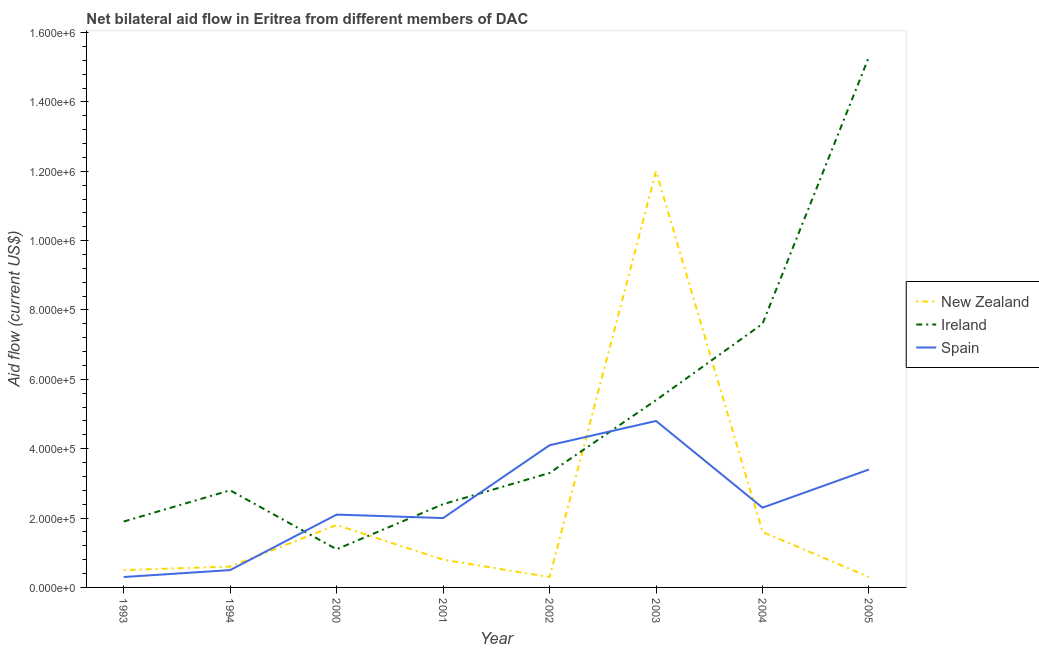Does the line corresponding to amount of aid provided by ireland intersect with the line corresponding to amount of aid provided by spain?
Your answer should be compact. Yes. Is the number of lines equal to the number of legend labels?
Keep it short and to the point. Yes. What is the amount of aid provided by ireland in 2001?
Provide a succinct answer. 2.40e+05. Across all years, what is the maximum amount of aid provided by new zealand?
Offer a terse response. 1.20e+06. Across all years, what is the minimum amount of aid provided by ireland?
Give a very brief answer. 1.10e+05. In which year was the amount of aid provided by new zealand maximum?
Provide a short and direct response. 2003. What is the total amount of aid provided by spain in the graph?
Provide a succinct answer. 1.95e+06. What is the difference between the amount of aid provided by ireland in 2002 and that in 2003?
Offer a terse response. -2.10e+05. What is the difference between the amount of aid provided by spain in 2005 and the amount of aid provided by new zealand in 1993?
Offer a terse response. 2.90e+05. What is the average amount of aid provided by spain per year?
Provide a short and direct response. 2.44e+05. In the year 2003, what is the difference between the amount of aid provided by spain and amount of aid provided by ireland?
Your answer should be very brief. -6.00e+04. In how many years, is the amount of aid provided by ireland greater than 600000 US$?
Provide a succinct answer. 2. What is the ratio of the amount of aid provided by ireland in 1993 to that in 2001?
Your answer should be compact. 0.79. Is the amount of aid provided by ireland in 2000 less than that in 2004?
Keep it short and to the point. Yes. Is the difference between the amount of aid provided by spain in 1993 and 2002 greater than the difference between the amount of aid provided by ireland in 1993 and 2002?
Keep it short and to the point. No. What is the difference between the highest and the lowest amount of aid provided by spain?
Ensure brevity in your answer.  4.50e+05. Is the sum of the amount of aid provided by new zealand in 2002 and 2003 greater than the maximum amount of aid provided by spain across all years?
Offer a terse response. Yes. Is it the case that in every year, the sum of the amount of aid provided by new zealand and amount of aid provided by ireland is greater than the amount of aid provided by spain?
Ensure brevity in your answer.  No. Does the amount of aid provided by ireland monotonically increase over the years?
Make the answer very short. No. Is the amount of aid provided by new zealand strictly greater than the amount of aid provided by ireland over the years?
Ensure brevity in your answer.  No. How many lines are there?
Give a very brief answer. 3. Does the graph contain any zero values?
Make the answer very short. No. Does the graph contain grids?
Give a very brief answer. No. Where does the legend appear in the graph?
Your answer should be compact. Center right. What is the title of the graph?
Your answer should be compact. Net bilateral aid flow in Eritrea from different members of DAC. Does "Refusal of sex" appear as one of the legend labels in the graph?
Make the answer very short. No. What is the label or title of the X-axis?
Your answer should be very brief. Year. What is the Aid flow (current US$) in New Zealand in 1993?
Make the answer very short. 5.00e+04. What is the Aid flow (current US$) in Ireland in 1993?
Offer a very short reply. 1.90e+05. What is the Aid flow (current US$) of New Zealand in 1994?
Your answer should be compact. 6.00e+04. What is the Aid flow (current US$) in Ireland in 1994?
Your response must be concise. 2.80e+05. What is the Aid flow (current US$) of New Zealand in 2000?
Provide a short and direct response. 1.80e+05. What is the Aid flow (current US$) of Spain in 2000?
Keep it short and to the point. 2.10e+05. What is the Aid flow (current US$) in New Zealand in 2001?
Keep it short and to the point. 8.00e+04. What is the Aid flow (current US$) of Ireland in 2001?
Your answer should be very brief. 2.40e+05. What is the Aid flow (current US$) of New Zealand in 2002?
Your response must be concise. 3.00e+04. What is the Aid flow (current US$) of Ireland in 2002?
Keep it short and to the point. 3.30e+05. What is the Aid flow (current US$) in Spain in 2002?
Your answer should be compact. 4.10e+05. What is the Aid flow (current US$) in New Zealand in 2003?
Provide a succinct answer. 1.20e+06. What is the Aid flow (current US$) of Ireland in 2003?
Your answer should be very brief. 5.40e+05. What is the Aid flow (current US$) of New Zealand in 2004?
Offer a very short reply. 1.60e+05. What is the Aid flow (current US$) of Ireland in 2004?
Provide a short and direct response. 7.60e+05. What is the Aid flow (current US$) of Ireland in 2005?
Your response must be concise. 1.53e+06. What is the Aid flow (current US$) of Spain in 2005?
Offer a very short reply. 3.40e+05. Across all years, what is the maximum Aid flow (current US$) in New Zealand?
Your answer should be compact. 1.20e+06. Across all years, what is the maximum Aid flow (current US$) in Ireland?
Make the answer very short. 1.53e+06. Across all years, what is the minimum Aid flow (current US$) in New Zealand?
Your response must be concise. 3.00e+04. Across all years, what is the minimum Aid flow (current US$) of Ireland?
Provide a succinct answer. 1.10e+05. Across all years, what is the minimum Aid flow (current US$) in Spain?
Keep it short and to the point. 3.00e+04. What is the total Aid flow (current US$) of New Zealand in the graph?
Offer a very short reply. 1.79e+06. What is the total Aid flow (current US$) in Ireland in the graph?
Make the answer very short. 3.98e+06. What is the total Aid flow (current US$) in Spain in the graph?
Your answer should be compact. 1.95e+06. What is the difference between the Aid flow (current US$) of Ireland in 1993 and that in 1994?
Offer a terse response. -9.00e+04. What is the difference between the Aid flow (current US$) of Spain in 1993 and that in 1994?
Offer a very short reply. -2.00e+04. What is the difference between the Aid flow (current US$) in Ireland in 1993 and that in 2000?
Make the answer very short. 8.00e+04. What is the difference between the Aid flow (current US$) of New Zealand in 1993 and that in 2001?
Give a very brief answer. -3.00e+04. What is the difference between the Aid flow (current US$) in Ireland in 1993 and that in 2001?
Your response must be concise. -5.00e+04. What is the difference between the Aid flow (current US$) of Ireland in 1993 and that in 2002?
Provide a short and direct response. -1.40e+05. What is the difference between the Aid flow (current US$) of Spain in 1993 and that in 2002?
Your answer should be compact. -3.80e+05. What is the difference between the Aid flow (current US$) in New Zealand in 1993 and that in 2003?
Offer a terse response. -1.15e+06. What is the difference between the Aid flow (current US$) of Ireland in 1993 and that in 2003?
Your answer should be compact. -3.50e+05. What is the difference between the Aid flow (current US$) in Spain in 1993 and that in 2003?
Offer a very short reply. -4.50e+05. What is the difference between the Aid flow (current US$) of New Zealand in 1993 and that in 2004?
Offer a very short reply. -1.10e+05. What is the difference between the Aid flow (current US$) of Ireland in 1993 and that in 2004?
Keep it short and to the point. -5.70e+05. What is the difference between the Aid flow (current US$) in Spain in 1993 and that in 2004?
Keep it short and to the point. -2.00e+05. What is the difference between the Aid flow (current US$) in New Zealand in 1993 and that in 2005?
Offer a terse response. 2.00e+04. What is the difference between the Aid flow (current US$) of Ireland in 1993 and that in 2005?
Provide a short and direct response. -1.34e+06. What is the difference between the Aid flow (current US$) in Spain in 1993 and that in 2005?
Ensure brevity in your answer.  -3.10e+05. What is the difference between the Aid flow (current US$) in Spain in 1994 and that in 2000?
Make the answer very short. -1.60e+05. What is the difference between the Aid flow (current US$) in New Zealand in 1994 and that in 2001?
Provide a short and direct response. -2.00e+04. What is the difference between the Aid flow (current US$) of Spain in 1994 and that in 2001?
Make the answer very short. -1.50e+05. What is the difference between the Aid flow (current US$) of Spain in 1994 and that in 2002?
Ensure brevity in your answer.  -3.60e+05. What is the difference between the Aid flow (current US$) in New Zealand in 1994 and that in 2003?
Offer a terse response. -1.14e+06. What is the difference between the Aid flow (current US$) in Ireland in 1994 and that in 2003?
Your response must be concise. -2.60e+05. What is the difference between the Aid flow (current US$) of Spain in 1994 and that in 2003?
Your answer should be very brief. -4.30e+05. What is the difference between the Aid flow (current US$) of New Zealand in 1994 and that in 2004?
Your answer should be very brief. -1.00e+05. What is the difference between the Aid flow (current US$) of Ireland in 1994 and that in 2004?
Offer a very short reply. -4.80e+05. What is the difference between the Aid flow (current US$) of Spain in 1994 and that in 2004?
Make the answer very short. -1.80e+05. What is the difference between the Aid flow (current US$) in Ireland in 1994 and that in 2005?
Keep it short and to the point. -1.25e+06. What is the difference between the Aid flow (current US$) in Spain in 2000 and that in 2001?
Provide a short and direct response. 10000. What is the difference between the Aid flow (current US$) in Spain in 2000 and that in 2002?
Provide a succinct answer. -2.00e+05. What is the difference between the Aid flow (current US$) of New Zealand in 2000 and that in 2003?
Make the answer very short. -1.02e+06. What is the difference between the Aid flow (current US$) of Ireland in 2000 and that in 2003?
Ensure brevity in your answer.  -4.30e+05. What is the difference between the Aid flow (current US$) of New Zealand in 2000 and that in 2004?
Provide a short and direct response. 2.00e+04. What is the difference between the Aid flow (current US$) of Ireland in 2000 and that in 2004?
Your answer should be very brief. -6.50e+05. What is the difference between the Aid flow (current US$) in Spain in 2000 and that in 2004?
Ensure brevity in your answer.  -2.00e+04. What is the difference between the Aid flow (current US$) in Ireland in 2000 and that in 2005?
Provide a short and direct response. -1.42e+06. What is the difference between the Aid flow (current US$) of New Zealand in 2001 and that in 2002?
Provide a succinct answer. 5.00e+04. What is the difference between the Aid flow (current US$) in Spain in 2001 and that in 2002?
Provide a short and direct response. -2.10e+05. What is the difference between the Aid flow (current US$) of New Zealand in 2001 and that in 2003?
Ensure brevity in your answer.  -1.12e+06. What is the difference between the Aid flow (current US$) in Spain in 2001 and that in 2003?
Make the answer very short. -2.80e+05. What is the difference between the Aid flow (current US$) of New Zealand in 2001 and that in 2004?
Keep it short and to the point. -8.00e+04. What is the difference between the Aid flow (current US$) of Ireland in 2001 and that in 2004?
Make the answer very short. -5.20e+05. What is the difference between the Aid flow (current US$) in Spain in 2001 and that in 2004?
Your response must be concise. -3.00e+04. What is the difference between the Aid flow (current US$) of Ireland in 2001 and that in 2005?
Offer a terse response. -1.29e+06. What is the difference between the Aid flow (current US$) in New Zealand in 2002 and that in 2003?
Your answer should be compact. -1.17e+06. What is the difference between the Aid flow (current US$) in Ireland in 2002 and that in 2003?
Give a very brief answer. -2.10e+05. What is the difference between the Aid flow (current US$) in New Zealand in 2002 and that in 2004?
Give a very brief answer. -1.30e+05. What is the difference between the Aid flow (current US$) of Ireland in 2002 and that in 2004?
Provide a short and direct response. -4.30e+05. What is the difference between the Aid flow (current US$) of Spain in 2002 and that in 2004?
Make the answer very short. 1.80e+05. What is the difference between the Aid flow (current US$) in New Zealand in 2002 and that in 2005?
Your answer should be compact. 0. What is the difference between the Aid flow (current US$) in Ireland in 2002 and that in 2005?
Your answer should be compact. -1.20e+06. What is the difference between the Aid flow (current US$) of Spain in 2002 and that in 2005?
Provide a short and direct response. 7.00e+04. What is the difference between the Aid flow (current US$) in New Zealand in 2003 and that in 2004?
Provide a succinct answer. 1.04e+06. What is the difference between the Aid flow (current US$) of Ireland in 2003 and that in 2004?
Give a very brief answer. -2.20e+05. What is the difference between the Aid flow (current US$) in New Zealand in 2003 and that in 2005?
Make the answer very short. 1.17e+06. What is the difference between the Aid flow (current US$) of Ireland in 2003 and that in 2005?
Your answer should be compact. -9.90e+05. What is the difference between the Aid flow (current US$) of New Zealand in 2004 and that in 2005?
Keep it short and to the point. 1.30e+05. What is the difference between the Aid flow (current US$) in Ireland in 2004 and that in 2005?
Offer a very short reply. -7.70e+05. What is the difference between the Aid flow (current US$) of New Zealand in 1993 and the Aid flow (current US$) of Ireland in 1994?
Keep it short and to the point. -2.30e+05. What is the difference between the Aid flow (current US$) in New Zealand in 1993 and the Aid flow (current US$) in Spain in 1994?
Ensure brevity in your answer.  0. What is the difference between the Aid flow (current US$) of New Zealand in 1993 and the Aid flow (current US$) of Ireland in 2000?
Offer a very short reply. -6.00e+04. What is the difference between the Aid flow (current US$) in New Zealand in 1993 and the Aid flow (current US$) in Spain in 2000?
Your response must be concise. -1.60e+05. What is the difference between the Aid flow (current US$) in Ireland in 1993 and the Aid flow (current US$) in Spain in 2000?
Offer a very short reply. -2.00e+04. What is the difference between the Aid flow (current US$) in New Zealand in 1993 and the Aid flow (current US$) in Ireland in 2001?
Your response must be concise. -1.90e+05. What is the difference between the Aid flow (current US$) of New Zealand in 1993 and the Aid flow (current US$) of Spain in 2001?
Your answer should be compact. -1.50e+05. What is the difference between the Aid flow (current US$) of New Zealand in 1993 and the Aid flow (current US$) of Ireland in 2002?
Keep it short and to the point. -2.80e+05. What is the difference between the Aid flow (current US$) in New Zealand in 1993 and the Aid flow (current US$) in Spain in 2002?
Ensure brevity in your answer.  -3.60e+05. What is the difference between the Aid flow (current US$) in Ireland in 1993 and the Aid flow (current US$) in Spain in 2002?
Your response must be concise. -2.20e+05. What is the difference between the Aid flow (current US$) of New Zealand in 1993 and the Aid flow (current US$) of Ireland in 2003?
Your response must be concise. -4.90e+05. What is the difference between the Aid flow (current US$) in New Zealand in 1993 and the Aid flow (current US$) in Spain in 2003?
Keep it short and to the point. -4.30e+05. What is the difference between the Aid flow (current US$) of New Zealand in 1993 and the Aid flow (current US$) of Ireland in 2004?
Offer a terse response. -7.10e+05. What is the difference between the Aid flow (current US$) of New Zealand in 1993 and the Aid flow (current US$) of Spain in 2004?
Provide a succinct answer. -1.80e+05. What is the difference between the Aid flow (current US$) in Ireland in 1993 and the Aid flow (current US$) in Spain in 2004?
Offer a terse response. -4.00e+04. What is the difference between the Aid flow (current US$) in New Zealand in 1993 and the Aid flow (current US$) in Ireland in 2005?
Your answer should be very brief. -1.48e+06. What is the difference between the Aid flow (current US$) in Ireland in 1993 and the Aid flow (current US$) in Spain in 2005?
Offer a very short reply. -1.50e+05. What is the difference between the Aid flow (current US$) of New Zealand in 1994 and the Aid flow (current US$) of Ireland in 2000?
Offer a terse response. -5.00e+04. What is the difference between the Aid flow (current US$) of Ireland in 1994 and the Aid flow (current US$) of Spain in 2000?
Ensure brevity in your answer.  7.00e+04. What is the difference between the Aid flow (current US$) of New Zealand in 1994 and the Aid flow (current US$) of Spain in 2001?
Provide a succinct answer. -1.40e+05. What is the difference between the Aid flow (current US$) of Ireland in 1994 and the Aid flow (current US$) of Spain in 2001?
Offer a terse response. 8.00e+04. What is the difference between the Aid flow (current US$) of New Zealand in 1994 and the Aid flow (current US$) of Spain in 2002?
Ensure brevity in your answer.  -3.50e+05. What is the difference between the Aid flow (current US$) of Ireland in 1994 and the Aid flow (current US$) of Spain in 2002?
Your answer should be compact. -1.30e+05. What is the difference between the Aid flow (current US$) of New Zealand in 1994 and the Aid flow (current US$) of Ireland in 2003?
Offer a terse response. -4.80e+05. What is the difference between the Aid flow (current US$) of New Zealand in 1994 and the Aid flow (current US$) of Spain in 2003?
Ensure brevity in your answer.  -4.20e+05. What is the difference between the Aid flow (current US$) of Ireland in 1994 and the Aid flow (current US$) of Spain in 2003?
Provide a succinct answer. -2.00e+05. What is the difference between the Aid flow (current US$) of New Zealand in 1994 and the Aid flow (current US$) of Ireland in 2004?
Offer a terse response. -7.00e+05. What is the difference between the Aid flow (current US$) in New Zealand in 1994 and the Aid flow (current US$) in Spain in 2004?
Offer a terse response. -1.70e+05. What is the difference between the Aid flow (current US$) of Ireland in 1994 and the Aid flow (current US$) of Spain in 2004?
Offer a very short reply. 5.00e+04. What is the difference between the Aid flow (current US$) of New Zealand in 1994 and the Aid flow (current US$) of Ireland in 2005?
Offer a terse response. -1.47e+06. What is the difference between the Aid flow (current US$) in New Zealand in 1994 and the Aid flow (current US$) in Spain in 2005?
Make the answer very short. -2.80e+05. What is the difference between the Aid flow (current US$) of New Zealand in 2000 and the Aid flow (current US$) of Spain in 2002?
Your response must be concise. -2.30e+05. What is the difference between the Aid flow (current US$) of New Zealand in 2000 and the Aid flow (current US$) of Ireland in 2003?
Keep it short and to the point. -3.60e+05. What is the difference between the Aid flow (current US$) of Ireland in 2000 and the Aid flow (current US$) of Spain in 2003?
Keep it short and to the point. -3.70e+05. What is the difference between the Aid flow (current US$) of New Zealand in 2000 and the Aid flow (current US$) of Ireland in 2004?
Give a very brief answer. -5.80e+05. What is the difference between the Aid flow (current US$) in New Zealand in 2000 and the Aid flow (current US$) in Spain in 2004?
Your answer should be compact. -5.00e+04. What is the difference between the Aid flow (current US$) in New Zealand in 2000 and the Aid flow (current US$) in Ireland in 2005?
Give a very brief answer. -1.35e+06. What is the difference between the Aid flow (current US$) of New Zealand in 2000 and the Aid flow (current US$) of Spain in 2005?
Offer a terse response. -1.60e+05. What is the difference between the Aid flow (current US$) of New Zealand in 2001 and the Aid flow (current US$) of Ireland in 2002?
Keep it short and to the point. -2.50e+05. What is the difference between the Aid flow (current US$) in New Zealand in 2001 and the Aid flow (current US$) in Spain in 2002?
Your answer should be very brief. -3.30e+05. What is the difference between the Aid flow (current US$) of New Zealand in 2001 and the Aid flow (current US$) of Ireland in 2003?
Keep it short and to the point. -4.60e+05. What is the difference between the Aid flow (current US$) of New Zealand in 2001 and the Aid flow (current US$) of Spain in 2003?
Give a very brief answer. -4.00e+05. What is the difference between the Aid flow (current US$) of Ireland in 2001 and the Aid flow (current US$) of Spain in 2003?
Offer a terse response. -2.40e+05. What is the difference between the Aid flow (current US$) in New Zealand in 2001 and the Aid flow (current US$) in Ireland in 2004?
Keep it short and to the point. -6.80e+05. What is the difference between the Aid flow (current US$) in Ireland in 2001 and the Aid flow (current US$) in Spain in 2004?
Your response must be concise. 10000. What is the difference between the Aid flow (current US$) in New Zealand in 2001 and the Aid flow (current US$) in Ireland in 2005?
Keep it short and to the point. -1.45e+06. What is the difference between the Aid flow (current US$) of New Zealand in 2001 and the Aid flow (current US$) of Spain in 2005?
Keep it short and to the point. -2.60e+05. What is the difference between the Aid flow (current US$) of Ireland in 2001 and the Aid flow (current US$) of Spain in 2005?
Offer a very short reply. -1.00e+05. What is the difference between the Aid flow (current US$) in New Zealand in 2002 and the Aid flow (current US$) in Ireland in 2003?
Keep it short and to the point. -5.10e+05. What is the difference between the Aid flow (current US$) in New Zealand in 2002 and the Aid flow (current US$) in Spain in 2003?
Offer a very short reply. -4.50e+05. What is the difference between the Aid flow (current US$) in Ireland in 2002 and the Aid flow (current US$) in Spain in 2003?
Give a very brief answer. -1.50e+05. What is the difference between the Aid flow (current US$) in New Zealand in 2002 and the Aid flow (current US$) in Ireland in 2004?
Your response must be concise. -7.30e+05. What is the difference between the Aid flow (current US$) in New Zealand in 2002 and the Aid flow (current US$) in Spain in 2004?
Your answer should be very brief. -2.00e+05. What is the difference between the Aid flow (current US$) in New Zealand in 2002 and the Aid flow (current US$) in Ireland in 2005?
Provide a short and direct response. -1.50e+06. What is the difference between the Aid flow (current US$) in New Zealand in 2002 and the Aid flow (current US$) in Spain in 2005?
Offer a very short reply. -3.10e+05. What is the difference between the Aid flow (current US$) of Ireland in 2002 and the Aid flow (current US$) of Spain in 2005?
Offer a terse response. -10000. What is the difference between the Aid flow (current US$) of New Zealand in 2003 and the Aid flow (current US$) of Ireland in 2004?
Make the answer very short. 4.40e+05. What is the difference between the Aid flow (current US$) in New Zealand in 2003 and the Aid flow (current US$) in Spain in 2004?
Your answer should be very brief. 9.70e+05. What is the difference between the Aid flow (current US$) of Ireland in 2003 and the Aid flow (current US$) of Spain in 2004?
Give a very brief answer. 3.10e+05. What is the difference between the Aid flow (current US$) of New Zealand in 2003 and the Aid flow (current US$) of Ireland in 2005?
Offer a terse response. -3.30e+05. What is the difference between the Aid flow (current US$) of New Zealand in 2003 and the Aid flow (current US$) of Spain in 2005?
Provide a short and direct response. 8.60e+05. What is the difference between the Aid flow (current US$) of New Zealand in 2004 and the Aid flow (current US$) of Ireland in 2005?
Make the answer very short. -1.37e+06. What is the difference between the Aid flow (current US$) of New Zealand in 2004 and the Aid flow (current US$) of Spain in 2005?
Give a very brief answer. -1.80e+05. What is the average Aid flow (current US$) in New Zealand per year?
Provide a succinct answer. 2.24e+05. What is the average Aid flow (current US$) in Ireland per year?
Make the answer very short. 4.98e+05. What is the average Aid flow (current US$) of Spain per year?
Keep it short and to the point. 2.44e+05. In the year 1993, what is the difference between the Aid flow (current US$) of New Zealand and Aid flow (current US$) of Spain?
Your response must be concise. 2.00e+04. In the year 1993, what is the difference between the Aid flow (current US$) of Ireland and Aid flow (current US$) of Spain?
Your answer should be compact. 1.60e+05. In the year 1994, what is the difference between the Aid flow (current US$) of Ireland and Aid flow (current US$) of Spain?
Offer a very short reply. 2.30e+05. In the year 2000, what is the difference between the Aid flow (current US$) of New Zealand and Aid flow (current US$) of Ireland?
Keep it short and to the point. 7.00e+04. In the year 2000, what is the difference between the Aid flow (current US$) in New Zealand and Aid flow (current US$) in Spain?
Offer a terse response. -3.00e+04. In the year 2001, what is the difference between the Aid flow (current US$) of New Zealand and Aid flow (current US$) of Spain?
Give a very brief answer. -1.20e+05. In the year 2001, what is the difference between the Aid flow (current US$) of Ireland and Aid flow (current US$) of Spain?
Your answer should be very brief. 4.00e+04. In the year 2002, what is the difference between the Aid flow (current US$) of New Zealand and Aid flow (current US$) of Spain?
Your answer should be compact. -3.80e+05. In the year 2002, what is the difference between the Aid flow (current US$) in Ireland and Aid flow (current US$) in Spain?
Make the answer very short. -8.00e+04. In the year 2003, what is the difference between the Aid flow (current US$) of New Zealand and Aid flow (current US$) of Spain?
Your response must be concise. 7.20e+05. In the year 2003, what is the difference between the Aid flow (current US$) of Ireland and Aid flow (current US$) of Spain?
Keep it short and to the point. 6.00e+04. In the year 2004, what is the difference between the Aid flow (current US$) of New Zealand and Aid flow (current US$) of Ireland?
Your answer should be compact. -6.00e+05. In the year 2004, what is the difference between the Aid flow (current US$) in New Zealand and Aid flow (current US$) in Spain?
Offer a terse response. -7.00e+04. In the year 2004, what is the difference between the Aid flow (current US$) in Ireland and Aid flow (current US$) in Spain?
Give a very brief answer. 5.30e+05. In the year 2005, what is the difference between the Aid flow (current US$) in New Zealand and Aid flow (current US$) in Ireland?
Make the answer very short. -1.50e+06. In the year 2005, what is the difference between the Aid flow (current US$) of New Zealand and Aid flow (current US$) of Spain?
Give a very brief answer. -3.10e+05. In the year 2005, what is the difference between the Aid flow (current US$) of Ireland and Aid flow (current US$) of Spain?
Offer a terse response. 1.19e+06. What is the ratio of the Aid flow (current US$) of Ireland in 1993 to that in 1994?
Give a very brief answer. 0.68. What is the ratio of the Aid flow (current US$) of New Zealand in 1993 to that in 2000?
Provide a short and direct response. 0.28. What is the ratio of the Aid flow (current US$) in Ireland in 1993 to that in 2000?
Make the answer very short. 1.73. What is the ratio of the Aid flow (current US$) of Spain in 1993 to that in 2000?
Your response must be concise. 0.14. What is the ratio of the Aid flow (current US$) in New Zealand in 1993 to that in 2001?
Provide a succinct answer. 0.62. What is the ratio of the Aid flow (current US$) of Ireland in 1993 to that in 2001?
Your answer should be compact. 0.79. What is the ratio of the Aid flow (current US$) of Spain in 1993 to that in 2001?
Your answer should be very brief. 0.15. What is the ratio of the Aid flow (current US$) of New Zealand in 1993 to that in 2002?
Keep it short and to the point. 1.67. What is the ratio of the Aid flow (current US$) of Ireland in 1993 to that in 2002?
Provide a succinct answer. 0.58. What is the ratio of the Aid flow (current US$) of Spain in 1993 to that in 2002?
Your answer should be very brief. 0.07. What is the ratio of the Aid flow (current US$) of New Zealand in 1993 to that in 2003?
Offer a terse response. 0.04. What is the ratio of the Aid flow (current US$) in Ireland in 1993 to that in 2003?
Give a very brief answer. 0.35. What is the ratio of the Aid flow (current US$) in Spain in 1993 to that in 2003?
Provide a short and direct response. 0.06. What is the ratio of the Aid flow (current US$) of New Zealand in 1993 to that in 2004?
Provide a short and direct response. 0.31. What is the ratio of the Aid flow (current US$) of Ireland in 1993 to that in 2004?
Offer a terse response. 0.25. What is the ratio of the Aid flow (current US$) in Spain in 1993 to that in 2004?
Your answer should be very brief. 0.13. What is the ratio of the Aid flow (current US$) of Ireland in 1993 to that in 2005?
Offer a very short reply. 0.12. What is the ratio of the Aid flow (current US$) of Spain in 1993 to that in 2005?
Make the answer very short. 0.09. What is the ratio of the Aid flow (current US$) of New Zealand in 1994 to that in 2000?
Provide a succinct answer. 0.33. What is the ratio of the Aid flow (current US$) in Ireland in 1994 to that in 2000?
Keep it short and to the point. 2.55. What is the ratio of the Aid flow (current US$) of Spain in 1994 to that in 2000?
Your answer should be very brief. 0.24. What is the ratio of the Aid flow (current US$) of New Zealand in 1994 to that in 2001?
Your answer should be compact. 0.75. What is the ratio of the Aid flow (current US$) in Ireland in 1994 to that in 2001?
Keep it short and to the point. 1.17. What is the ratio of the Aid flow (current US$) of Spain in 1994 to that in 2001?
Your response must be concise. 0.25. What is the ratio of the Aid flow (current US$) of New Zealand in 1994 to that in 2002?
Ensure brevity in your answer.  2. What is the ratio of the Aid flow (current US$) in Ireland in 1994 to that in 2002?
Offer a terse response. 0.85. What is the ratio of the Aid flow (current US$) in Spain in 1994 to that in 2002?
Provide a short and direct response. 0.12. What is the ratio of the Aid flow (current US$) in New Zealand in 1994 to that in 2003?
Provide a succinct answer. 0.05. What is the ratio of the Aid flow (current US$) in Ireland in 1994 to that in 2003?
Provide a succinct answer. 0.52. What is the ratio of the Aid flow (current US$) of Spain in 1994 to that in 2003?
Offer a terse response. 0.1. What is the ratio of the Aid flow (current US$) of New Zealand in 1994 to that in 2004?
Offer a very short reply. 0.38. What is the ratio of the Aid flow (current US$) of Ireland in 1994 to that in 2004?
Ensure brevity in your answer.  0.37. What is the ratio of the Aid flow (current US$) of Spain in 1994 to that in 2004?
Your response must be concise. 0.22. What is the ratio of the Aid flow (current US$) of Ireland in 1994 to that in 2005?
Make the answer very short. 0.18. What is the ratio of the Aid flow (current US$) in Spain in 1994 to that in 2005?
Your answer should be very brief. 0.15. What is the ratio of the Aid flow (current US$) in New Zealand in 2000 to that in 2001?
Ensure brevity in your answer.  2.25. What is the ratio of the Aid flow (current US$) of Ireland in 2000 to that in 2001?
Give a very brief answer. 0.46. What is the ratio of the Aid flow (current US$) in Spain in 2000 to that in 2001?
Ensure brevity in your answer.  1.05. What is the ratio of the Aid flow (current US$) in New Zealand in 2000 to that in 2002?
Keep it short and to the point. 6. What is the ratio of the Aid flow (current US$) of Ireland in 2000 to that in 2002?
Give a very brief answer. 0.33. What is the ratio of the Aid flow (current US$) in Spain in 2000 to that in 2002?
Provide a succinct answer. 0.51. What is the ratio of the Aid flow (current US$) in Ireland in 2000 to that in 2003?
Offer a very short reply. 0.2. What is the ratio of the Aid flow (current US$) in Spain in 2000 to that in 2003?
Your answer should be compact. 0.44. What is the ratio of the Aid flow (current US$) in New Zealand in 2000 to that in 2004?
Give a very brief answer. 1.12. What is the ratio of the Aid flow (current US$) in Ireland in 2000 to that in 2004?
Offer a terse response. 0.14. What is the ratio of the Aid flow (current US$) in New Zealand in 2000 to that in 2005?
Offer a very short reply. 6. What is the ratio of the Aid flow (current US$) of Ireland in 2000 to that in 2005?
Provide a succinct answer. 0.07. What is the ratio of the Aid flow (current US$) in Spain in 2000 to that in 2005?
Your response must be concise. 0.62. What is the ratio of the Aid flow (current US$) of New Zealand in 2001 to that in 2002?
Provide a short and direct response. 2.67. What is the ratio of the Aid flow (current US$) in Ireland in 2001 to that in 2002?
Offer a very short reply. 0.73. What is the ratio of the Aid flow (current US$) of Spain in 2001 to that in 2002?
Ensure brevity in your answer.  0.49. What is the ratio of the Aid flow (current US$) in New Zealand in 2001 to that in 2003?
Ensure brevity in your answer.  0.07. What is the ratio of the Aid flow (current US$) in Ireland in 2001 to that in 2003?
Your response must be concise. 0.44. What is the ratio of the Aid flow (current US$) in Spain in 2001 to that in 2003?
Your answer should be compact. 0.42. What is the ratio of the Aid flow (current US$) of Ireland in 2001 to that in 2004?
Give a very brief answer. 0.32. What is the ratio of the Aid flow (current US$) in Spain in 2001 to that in 2004?
Provide a succinct answer. 0.87. What is the ratio of the Aid flow (current US$) in New Zealand in 2001 to that in 2005?
Offer a very short reply. 2.67. What is the ratio of the Aid flow (current US$) of Ireland in 2001 to that in 2005?
Offer a very short reply. 0.16. What is the ratio of the Aid flow (current US$) of Spain in 2001 to that in 2005?
Your answer should be very brief. 0.59. What is the ratio of the Aid flow (current US$) of New Zealand in 2002 to that in 2003?
Give a very brief answer. 0.03. What is the ratio of the Aid flow (current US$) of Ireland in 2002 to that in 2003?
Provide a succinct answer. 0.61. What is the ratio of the Aid flow (current US$) of Spain in 2002 to that in 2003?
Your response must be concise. 0.85. What is the ratio of the Aid flow (current US$) of New Zealand in 2002 to that in 2004?
Ensure brevity in your answer.  0.19. What is the ratio of the Aid flow (current US$) of Ireland in 2002 to that in 2004?
Make the answer very short. 0.43. What is the ratio of the Aid flow (current US$) in Spain in 2002 to that in 2004?
Make the answer very short. 1.78. What is the ratio of the Aid flow (current US$) in New Zealand in 2002 to that in 2005?
Your answer should be compact. 1. What is the ratio of the Aid flow (current US$) in Ireland in 2002 to that in 2005?
Offer a terse response. 0.22. What is the ratio of the Aid flow (current US$) of Spain in 2002 to that in 2005?
Your answer should be compact. 1.21. What is the ratio of the Aid flow (current US$) of Ireland in 2003 to that in 2004?
Give a very brief answer. 0.71. What is the ratio of the Aid flow (current US$) in Spain in 2003 to that in 2004?
Your answer should be very brief. 2.09. What is the ratio of the Aid flow (current US$) in Ireland in 2003 to that in 2005?
Keep it short and to the point. 0.35. What is the ratio of the Aid flow (current US$) in Spain in 2003 to that in 2005?
Provide a succinct answer. 1.41. What is the ratio of the Aid flow (current US$) of New Zealand in 2004 to that in 2005?
Your answer should be compact. 5.33. What is the ratio of the Aid flow (current US$) in Ireland in 2004 to that in 2005?
Provide a short and direct response. 0.5. What is the ratio of the Aid flow (current US$) in Spain in 2004 to that in 2005?
Keep it short and to the point. 0.68. What is the difference between the highest and the second highest Aid flow (current US$) in New Zealand?
Keep it short and to the point. 1.02e+06. What is the difference between the highest and the second highest Aid flow (current US$) of Ireland?
Make the answer very short. 7.70e+05. What is the difference between the highest and the lowest Aid flow (current US$) of New Zealand?
Ensure brevity in your answer.  1.17e+06. What is the difference between the highest and the lowest Aid flow (current US$) in Ireland?
Keep it short and to the point. 1.42e+06. 